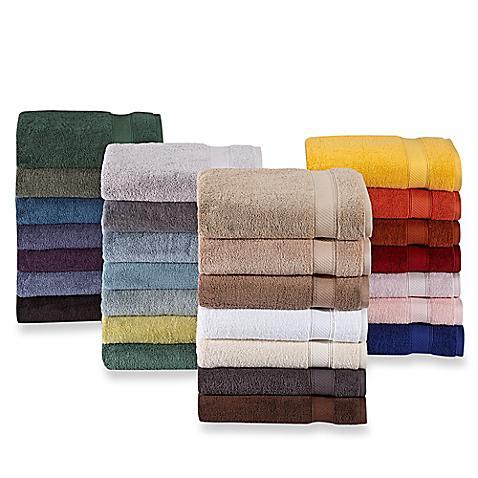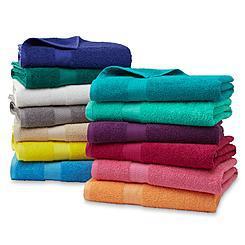The first image is the image on the left, the second image is the image on the right. Given the left and right images, does the statement "Each image shows exactly two piles of multiple towels in different solid colors." hold true? Answer yes or no. No. 